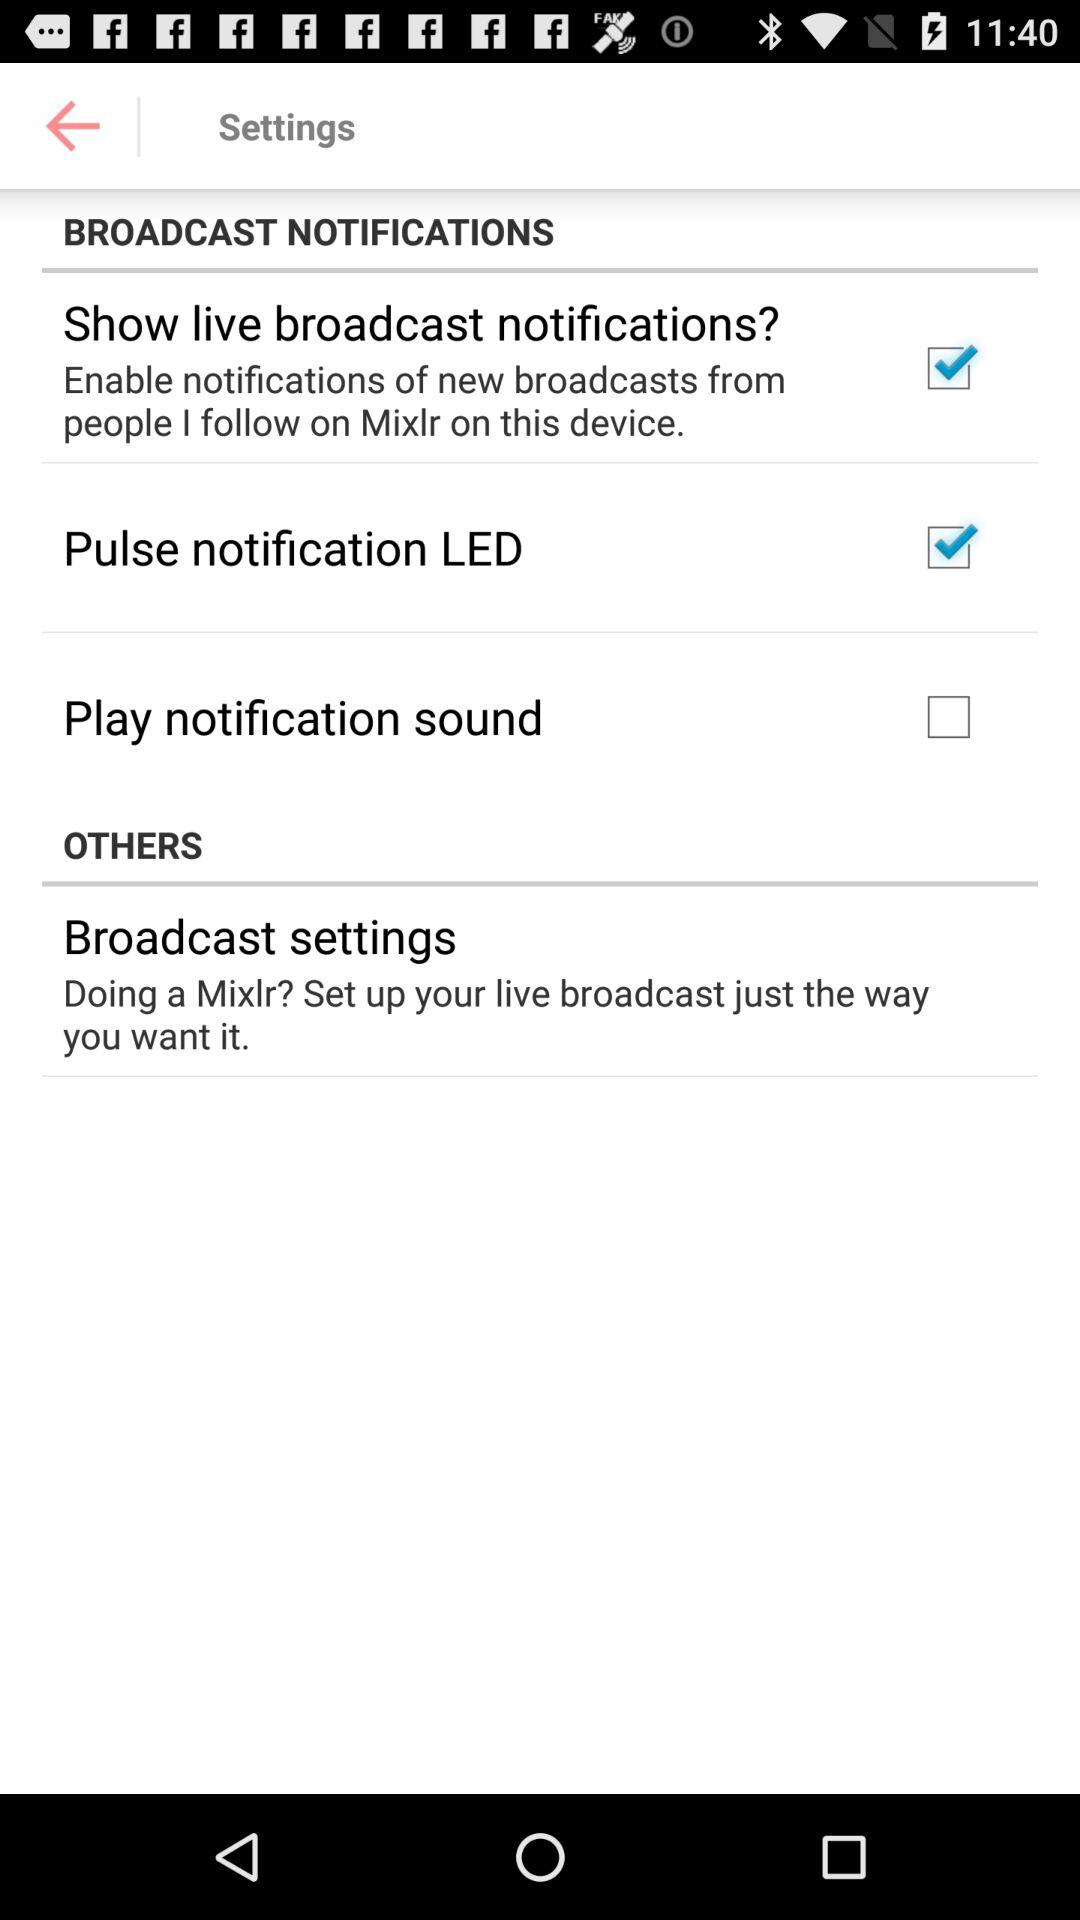Is "OTHERS" selected or not selected?
When the provided information is insufficient, respond with <no answer>. <no answer> 